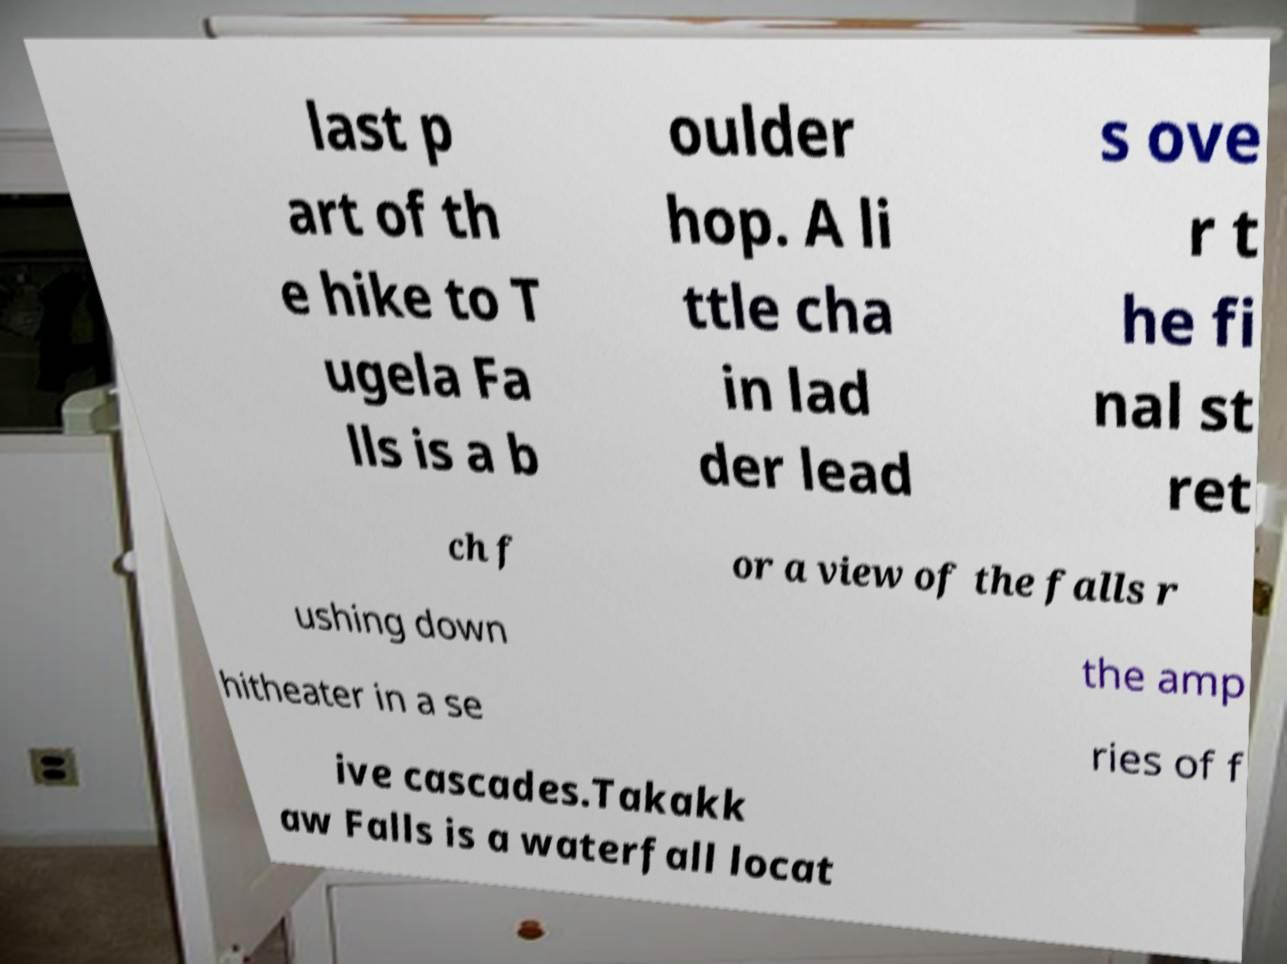Please read and relay the text visible in this image. What does it say? last p art of th e hike to T ugela Fa lls is a b oulder hop. A li ttle cha in lad der lead s ove r t he fi nal st ret ch f or a view of the falls r ushing down the amp hitheater in a se ries of f ive cascades.Takakk aw Falls is a waterfall locat 